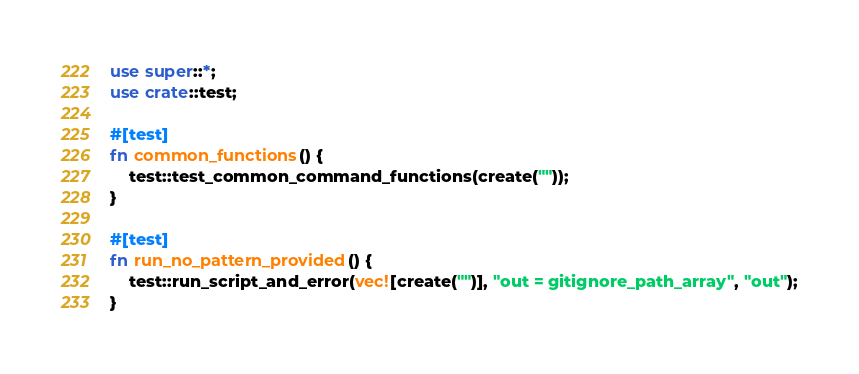Convert code to text. <code><loc_0><loc_0><loc_500><loc_500><_Rust_>use super::*;
use crate::test;

#[test]
fn common_functions() {
    test::test_common_command_functions(create(""));
}

#[test]
fn run_no_pattern_provided() {
    test::run_script_and_error(vec![create("")], "out = gitignore_path_array", "out");
}
</code> 